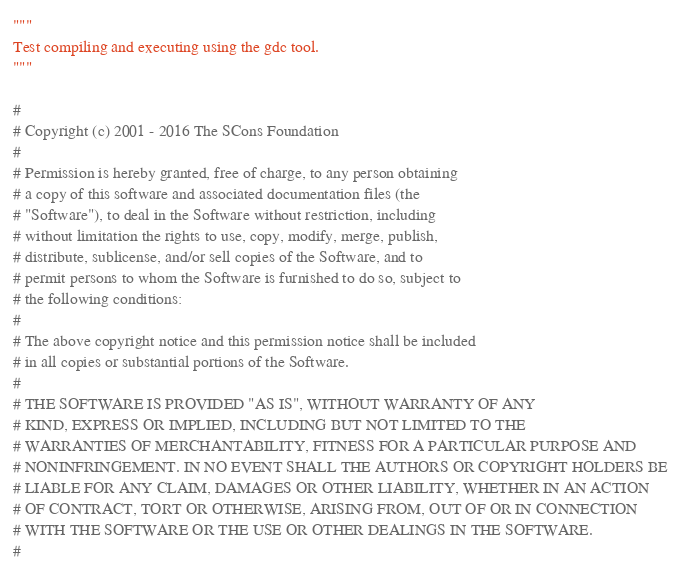Convert code to text. <code><loc_0><loc_0><loc_500><loc_500><_Python_>"""
Test compiling and executing using the gdc tool.
"""

#
# Copyright (c) 2001 - 2016 The SCons Foundation
#
# Permission is hereby granted, free of charge, to any person obtaining
# a copy of this software and associated documentation files (the
# "Software"), to deal in the Software without restriction, including
# without limitation the rights to use, copy, modify, merge, publish,
# distribute, sublicense, and/or sell copies of the Software, and to
# permit persons to whom the Software is furnished to do so, subject to
# the following conditions:
#
# The above copyright notice and this permission notice shall be included
# in all copies or substantial portions of the Software.
#
# THE SOFTWARE IS PROVIDED "AS IS", WITHOUT WARRANTY OF ANY
# KIND, EXPRESS OR IMPLIED, INCLUDING BUT NOT LIMITED TO THE
# WARRANTIES OF MERCHANTABILITY, FITNESS FOR A PARTICULAR PURPOSE AND
# NONINFRINGEMENT. IN NO EVENT SHALL THE AUTHORS OR COPYRIGHT HOLDERS BE
# LIABLE FOR ANY CLAIM, DAMAGES OR OTHER LIABILITY, WHETHER IN AN ACTION
# OF CONTRACT, TORT OR OTHERWISE, ARISING FROM, OUT OF OR IN CONNECTION
# WITH THE SOFTWARE OR THE USE OR OTHER DEALINGS IN THE SOFTWARE.
#
</code> 